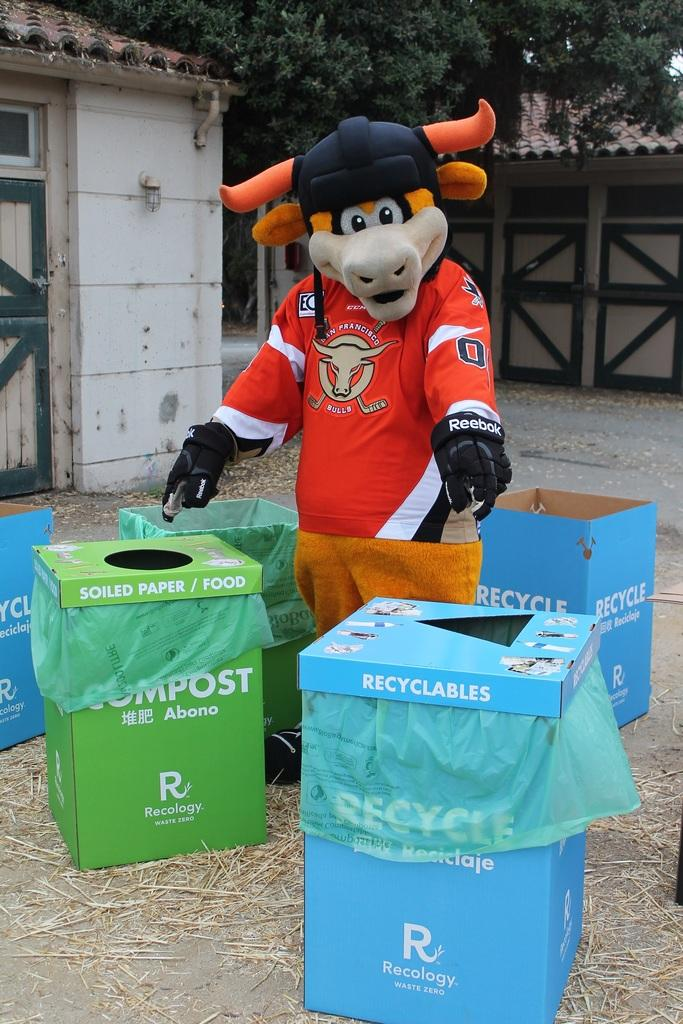<image>
Present a compact description of the photo's key features. A Bull mascot stands in front of a blue reclyclables trash can 